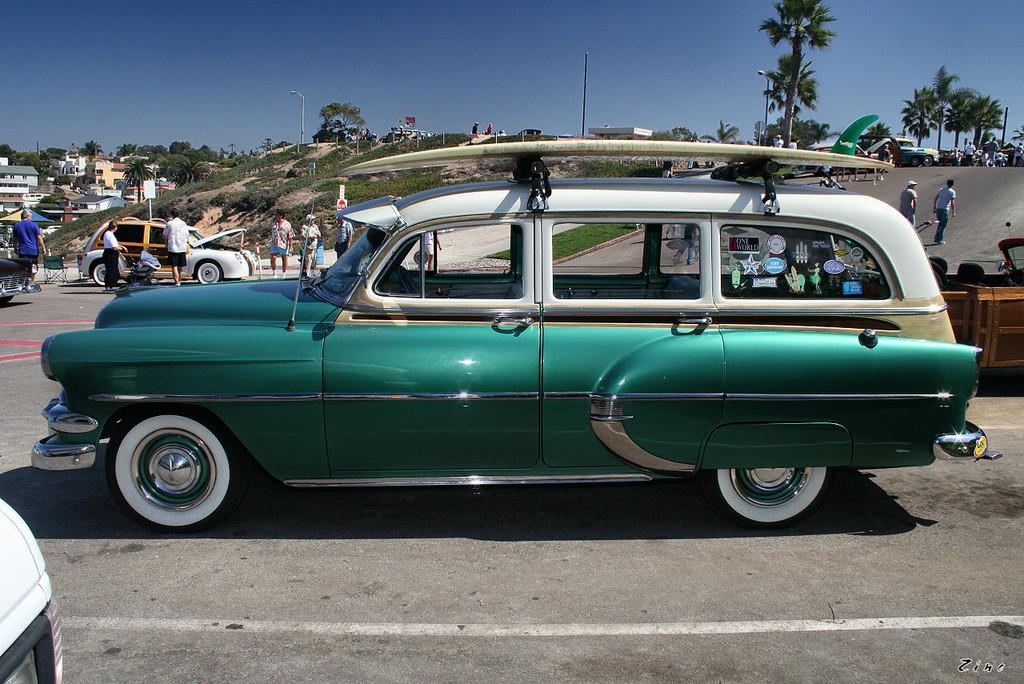What types of objects can be seen in the image? There are vehicles, people, buildings, trees, lights, and some objects in the image. Can you describe the setting of the image? The image features vehicles, people, buildings, trees, and lights, which suggests an urban or city environment. What is visible in the background of the image? The sky is visible in the background of the image. How many rings are visible on the girl's finger in the image? There is no girl present in the image, so it is not possible to determine the number of rings on her finger. What type of brick is used to construct the buildings in the image? There is no specific mention of the type of brick used in the construction of the buildings in the image. 